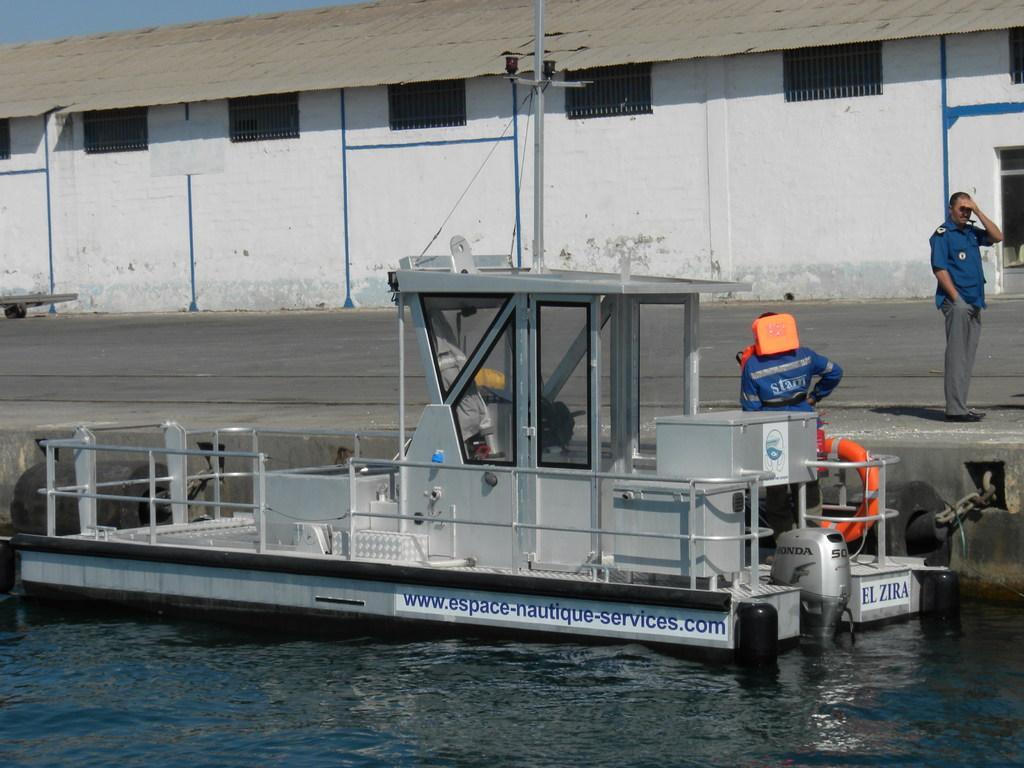Can you describe this image briefly? In this image there is water and we can see a boat on the water and there are people. In the background we can see a shed. At the top there is sky. 